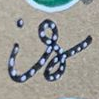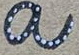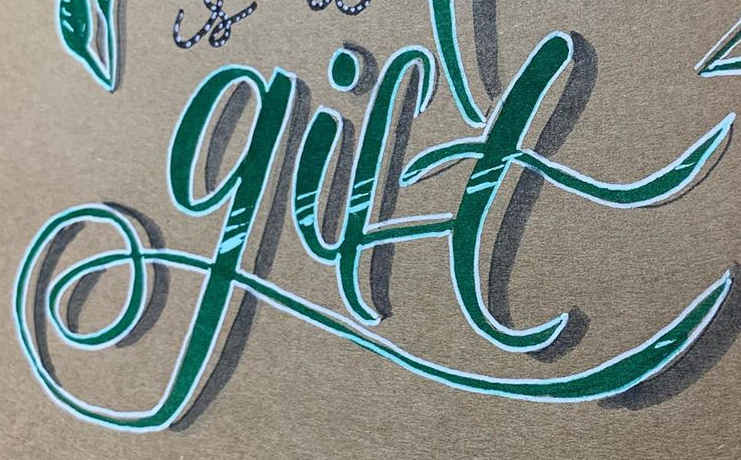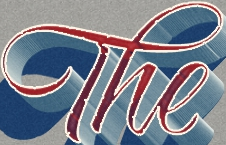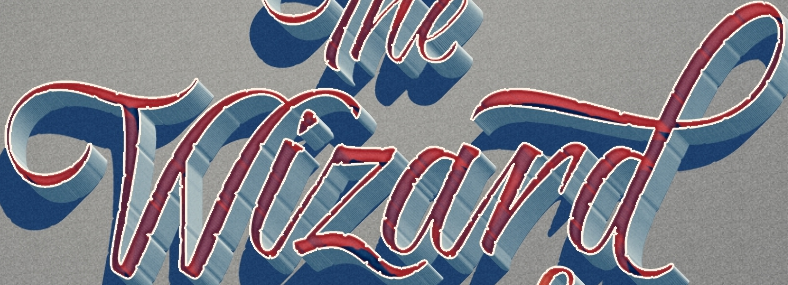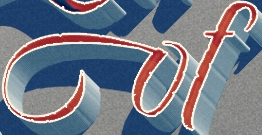What words are shown in these images in order, separated by a semicolon? is; a; gift; The; Wizard; of 